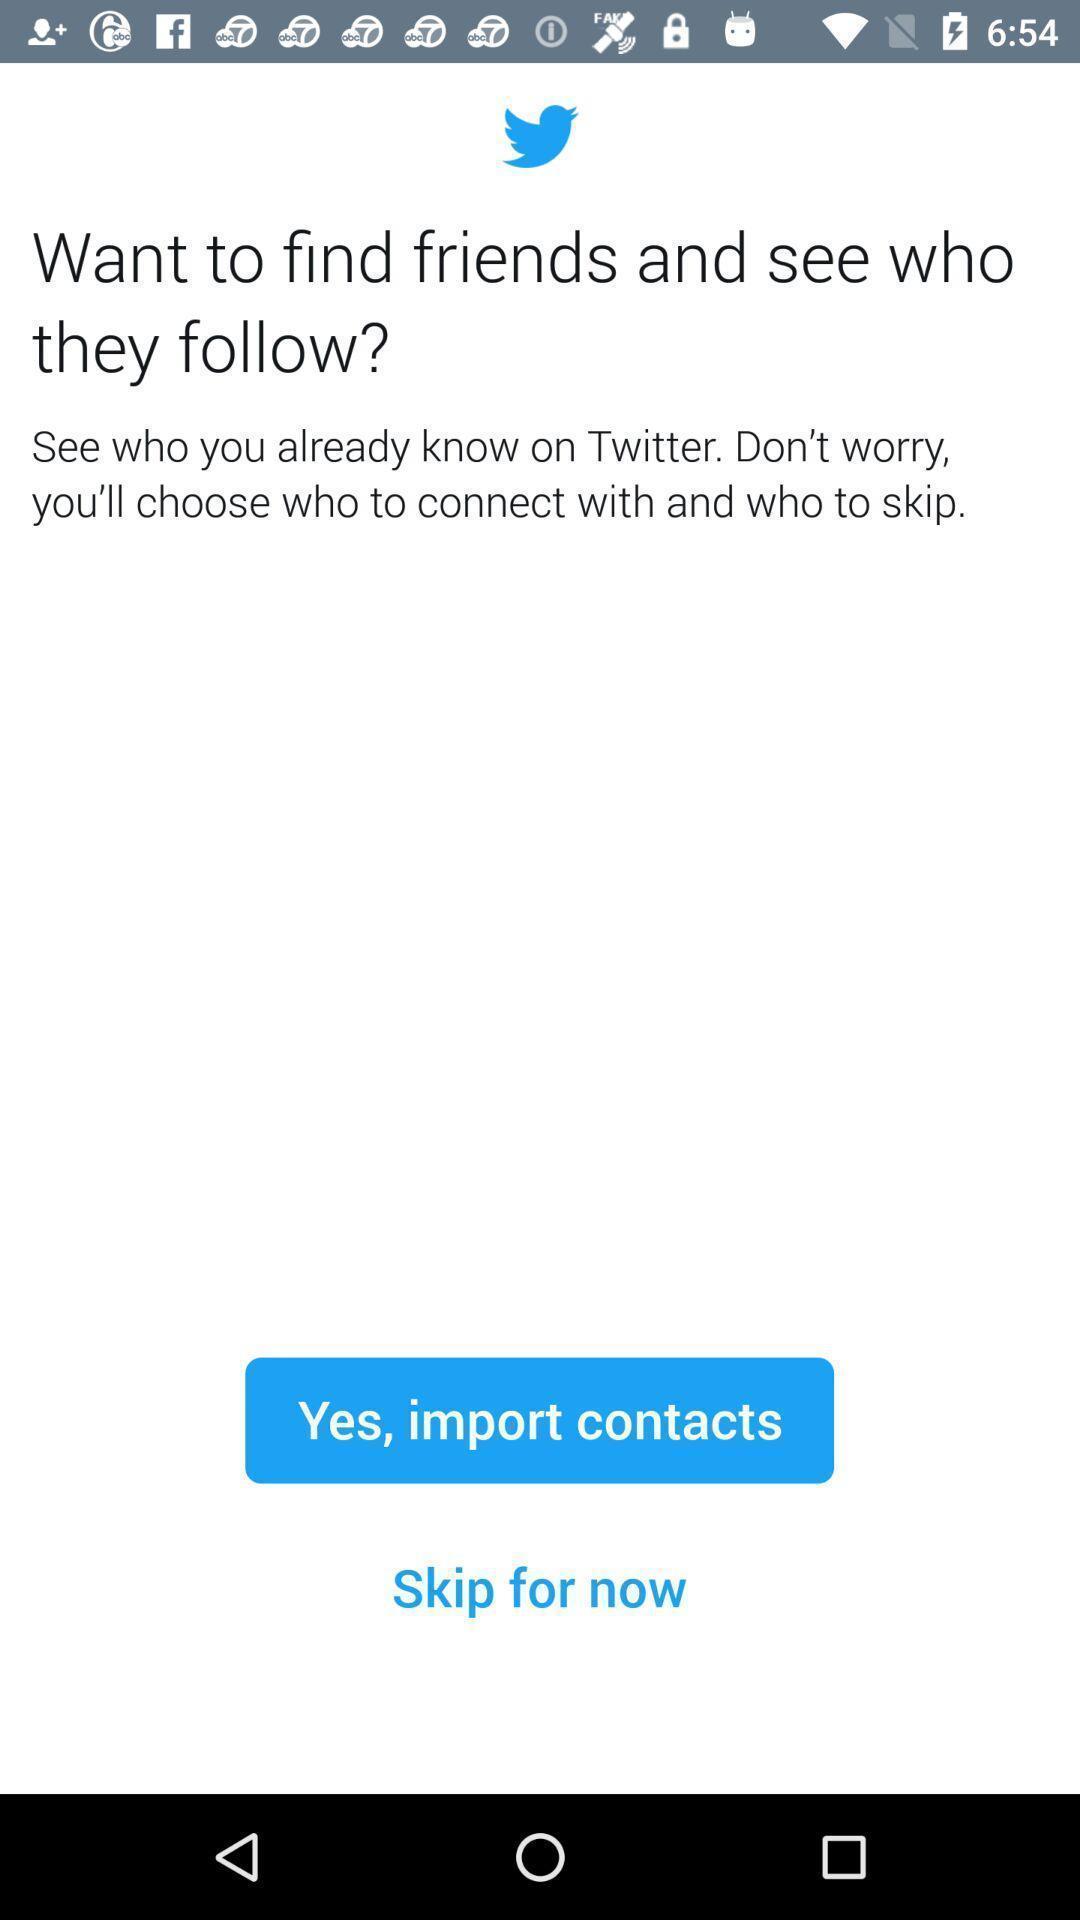Explain the elements present in this screenshot. Screen shows to find friends and import contacts. 